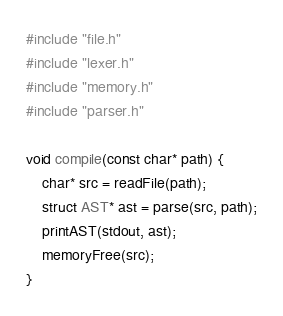<code> <loc_0><loc_0><loc_500><loc_500><_C_>#include "file.h"
#include "lexer.h"
#include "memory.h"
#include "parser.h"

void compile(const char* path) {
    char* src = readFile(path);
    struct AST* ast = parse(src, path);
    printAST(stdout, ast);
    memoryFree(src);
}
</code> 